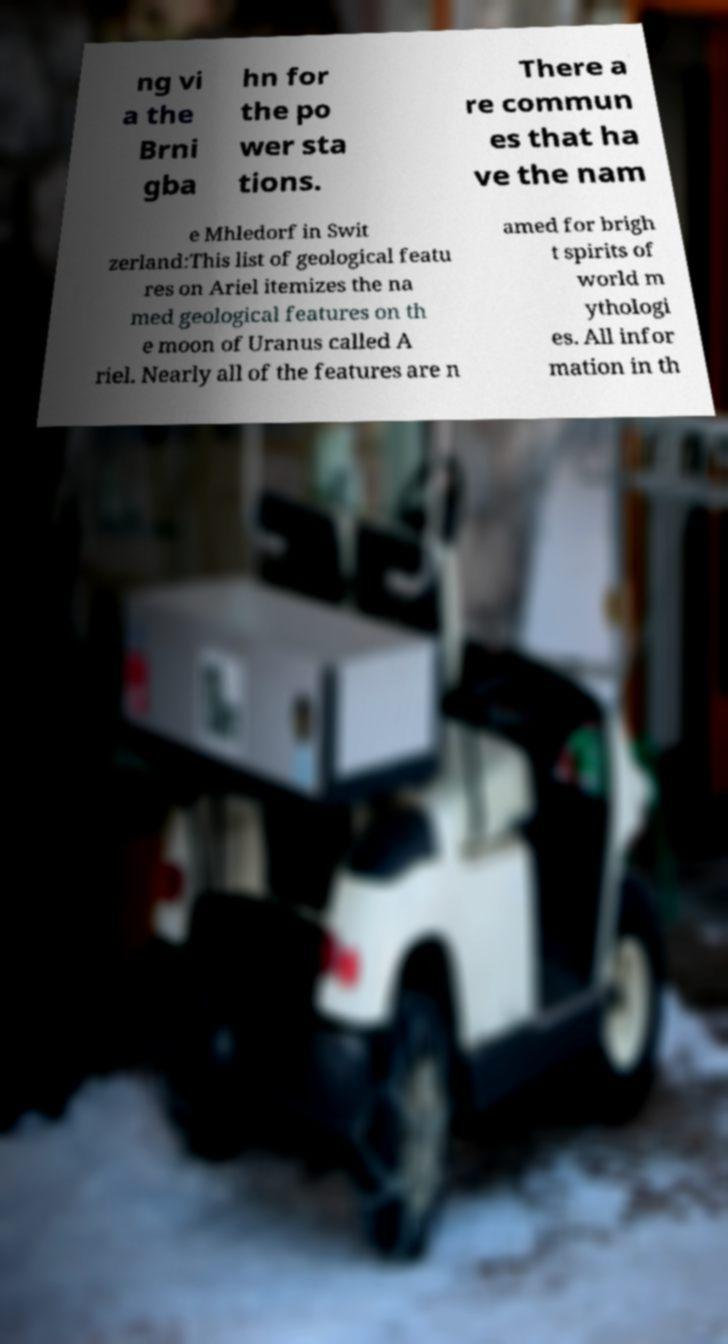For documentation purposes, I need the text within this image transcribed. Could you provide that? ng vi a the Brni gba hn for the po wer sta tions. There a re commun es that ha ve the nam e Mhledorf in Swit zerland:This list of geological featu res on Ariel itemizes the na med geological features on th e moon of Uranus called A riel. Nearly all of the features are n amed for brigh t spirits of world m ythologi es. All infor mation in th 